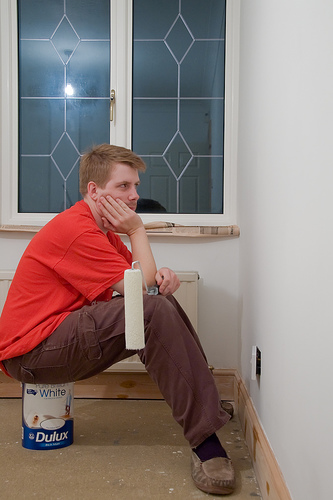<image>
Is the man next to the can? No. The man is not positioned next to the can. They are located in different areas of the scene. 